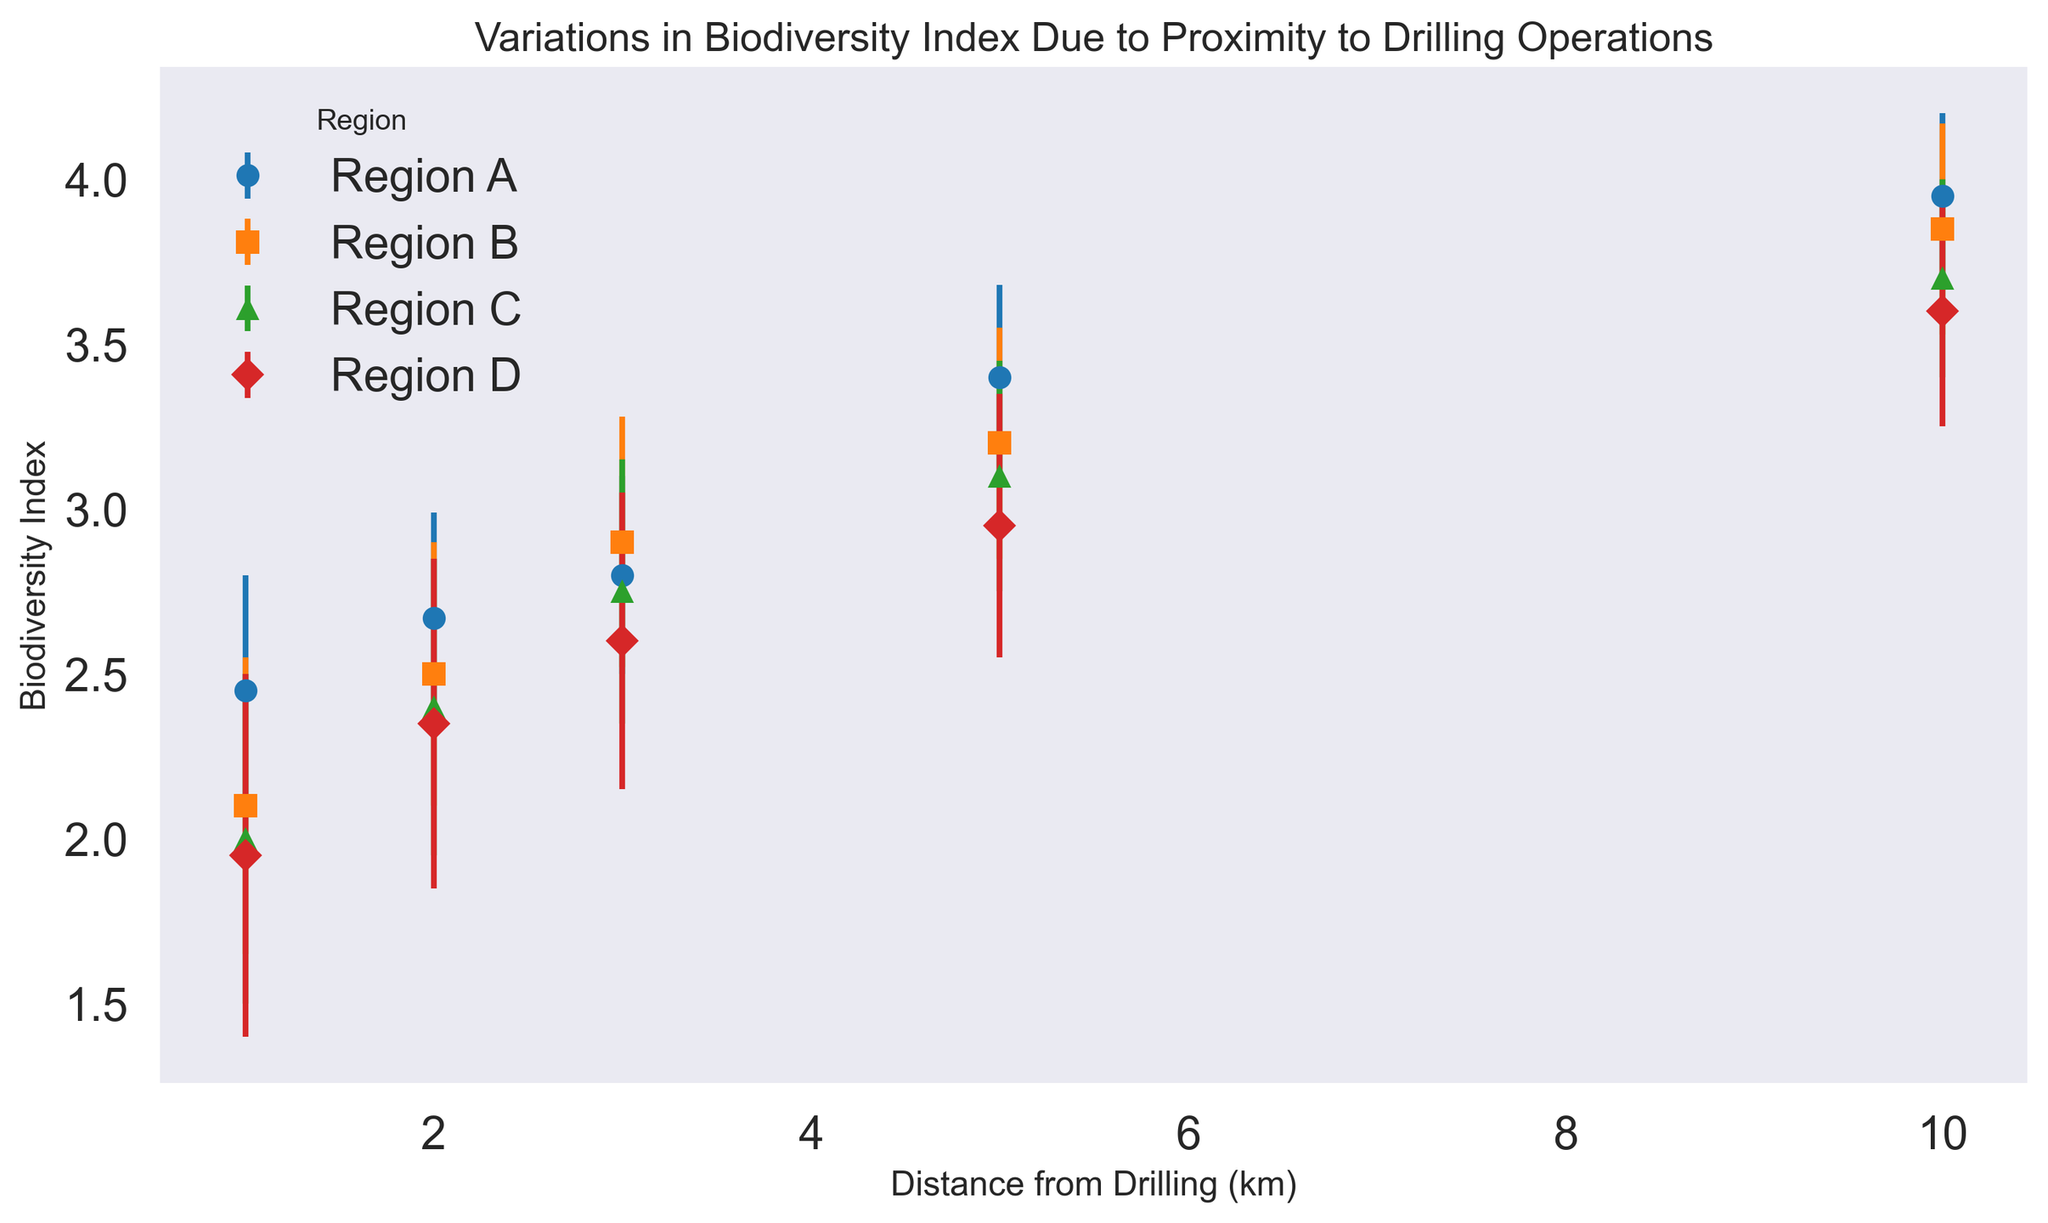What is the average Biodiversity Index at 5 km from drilling across all regions? First, find the Biodiversity Index at 5 km for each region: A(3.40), B(3.20), C(3.10), D(2.95). Summing these values gives 3.40 + 3.20 + 3.10 + 2.95 = 12.65. Dividing by the number of regions (4), the average is 12.65 / 4 = 3.1625
Answer: 3.16 Which region shows the highest Biodiversity Index at a distance of 1 km from drilling? Looking at the Biodiversity Index values at 1 km for each region: A(2.45), B(2.10), C(2.00), D(1.95). Region A has the highest value of 2.45
Answer: Region A Between Regions B and D, which one has a higher Biodiversity Index at 3 km from drilling? The Biodiversity Index at 3 km for Region B is 2.90 and for Region D is 2.60. Region B has a higher index value of 2.90
Answer: Region B What is the difference in the Biodiversity Index between the closest and farthest distances from drilling for Region A? For Region A, the Biodiversity Index at 1 km is 2.45, and at 10 km, it is 3.95. The difference is 3.95 - 2.45 = 1.50
Answer: 1.50 Which region shows the smallest change in Biodiversity Index from 1 km to 10 km from drilling? Calculate the change for each region: A(3.95 - 2.45 = 1.50), B(3.85 - 2.10 = 1.75), C(3.70 - 2.00 = 1.70), D(3.60 - 1.95 = 1.65). The smallest change is for Region A with 1.50
Answer: Region A How does the Biodiversity Index at 5 km from drilling compare between Region A and Region C? The Biodiversity Index at 5 km for Region A is 3.40, and for Region C, it is 3.10. Region A has a higher index value of 3.40 compared to Region C's 3.10
Answer: Region A What is the trend in Biodiversity Index as the distance from drilling increases for Region D? Observe the Biodiversity Index values for Region D: 1.95 (1 km), 2.35 (2 km), 2.60 (3 km), 2.95 (5 km), 3.60 (10 km). The values increase as the distance increases, showing an upward trend
Answer: Increasing Comparing the standard deviations, which region shows the most variability in Biodiversity Index at 1 km from drilling? The standard deviations at 1 km for each region are: A(0.35), B(0.45), C(0.50), D(0.55). Region D has the highest standard deviation of 0.55
Answer: Region D 